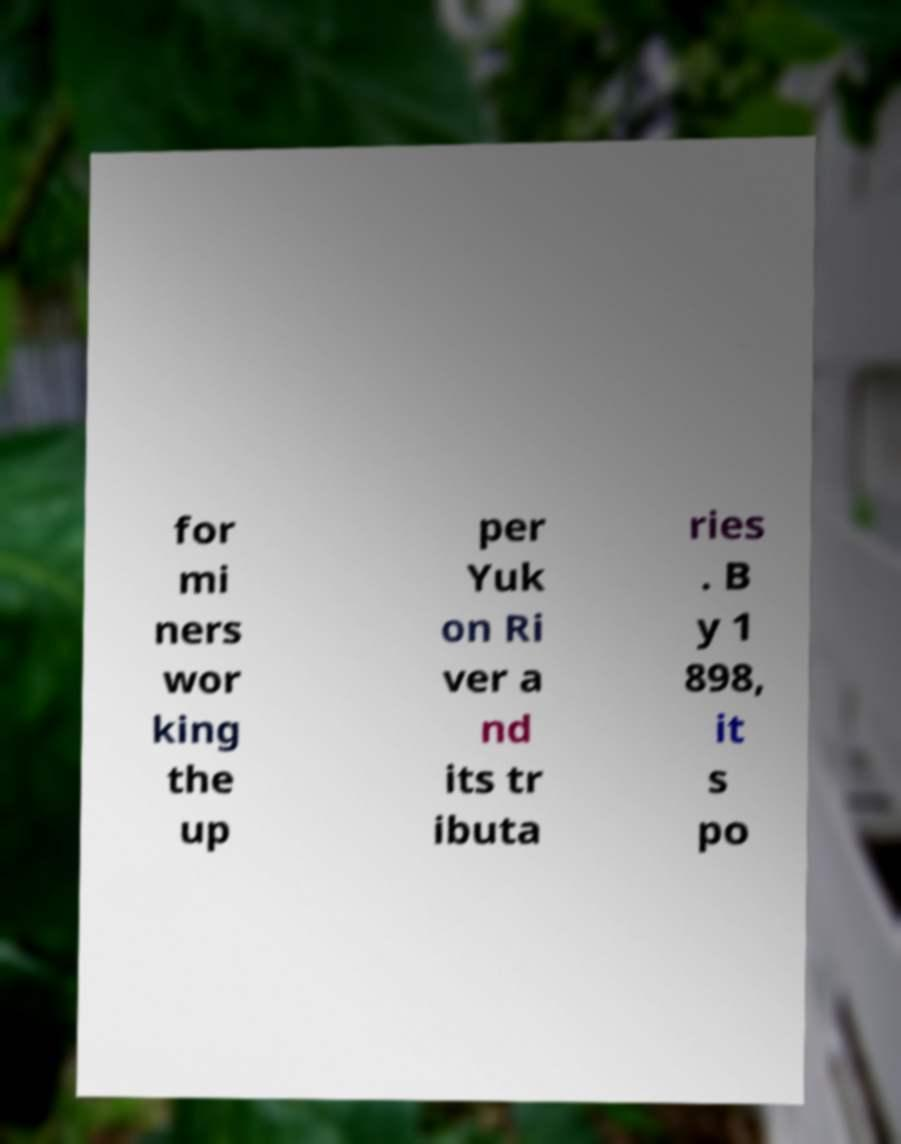Could you assist in decoding the text presented in this image and type it out clearly? for mi ners wor king the up per Yuk on Ri ver a nd its tr ibuta ries . B y 1 898, it s po 